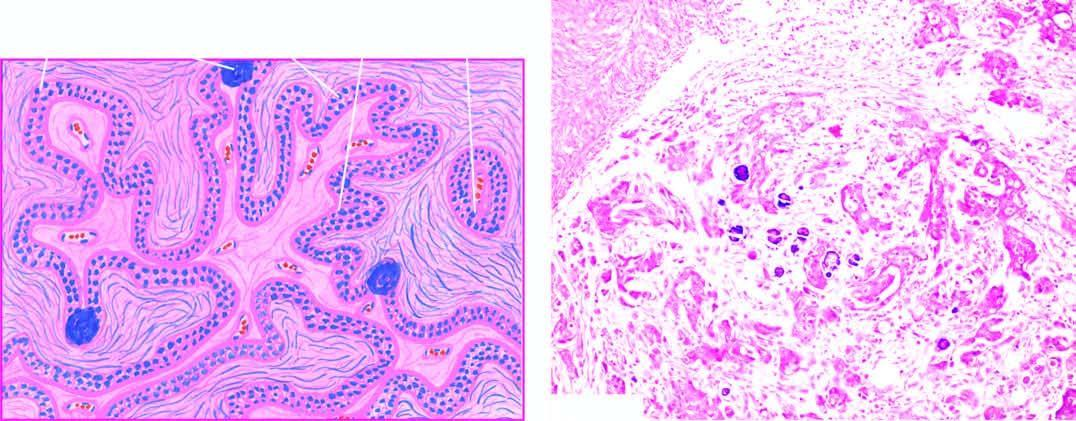do the capillary walls include stratification of low columnar epithelium lining the inner surface of the cyst and a few psammoma bodies?
Answer the question using a single word or phrase. No 